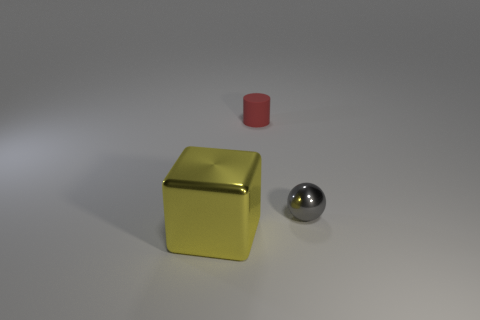Add 1 big yellow shiny things. How many objects exist? 4 Subtract 1 balls. How many balls are left? 0 Subtract all spheres. How many objects are left? 2 Subtract all yellow cylinders. Subtract all gray balls. How many objects are left? 2 Add 2 big metallic blocks. How many big metallic blocks are left? 3 Add 1 gray metal balls. How many gray metal balls exist? 2 Subtract 0 cyan spheres. How many objects are left? 3 